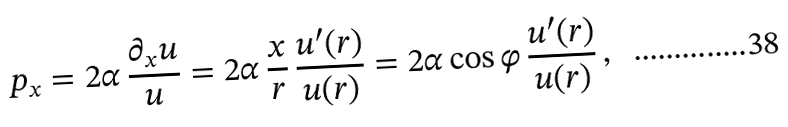<formula> <loc_0><loc_0><loc_500><loc_500>p _ { x } = 2 \alpha \, \frac { \partial _ { x } u } { u } = 2 \alpha \, \frac { x } { r } \, \frac { u ^ { \prime } ( r ) } { u ( r ) } = 2 \alpha \cos \varphi \, \frac { u ^ { \prime } ( r ) } { u ( r ) } \, ,</formula> 